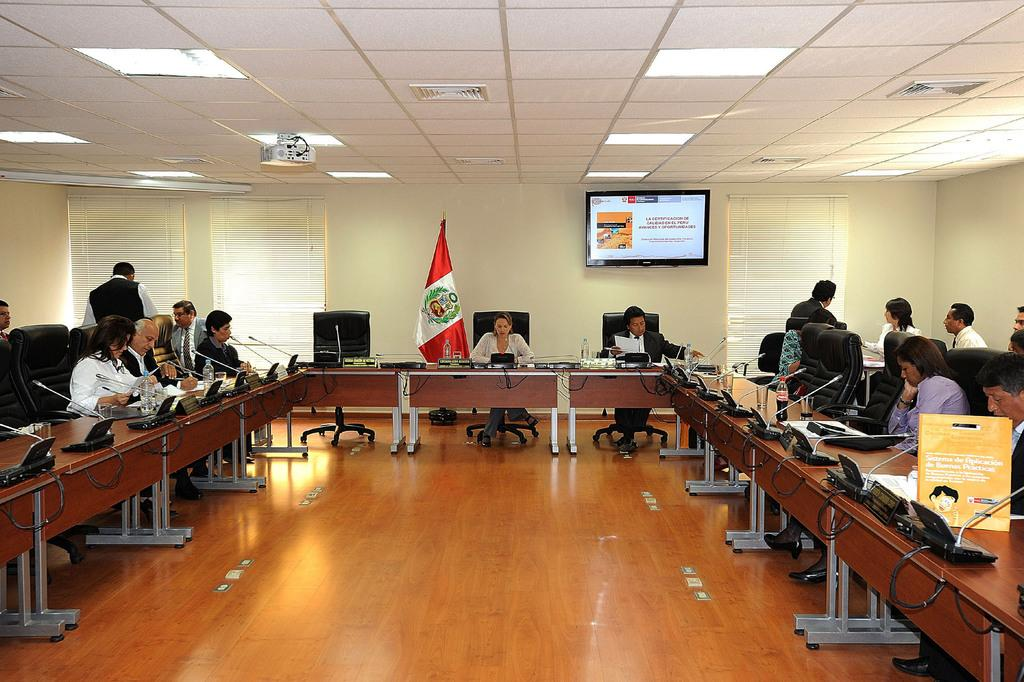What are the people in the image doing? The people in the image are sitting on chairs. What can be seen in the image besides the people sitting on chairs? There is a flag, a wall, a window blind, a person standing, and a television screen in the background of the image. What type of angle is being used to fly the planes in the image? There are no planes present in the image. How does the brake work on the television screen in the image? The television screen in the image is not a vehicle and does not have a brake. 